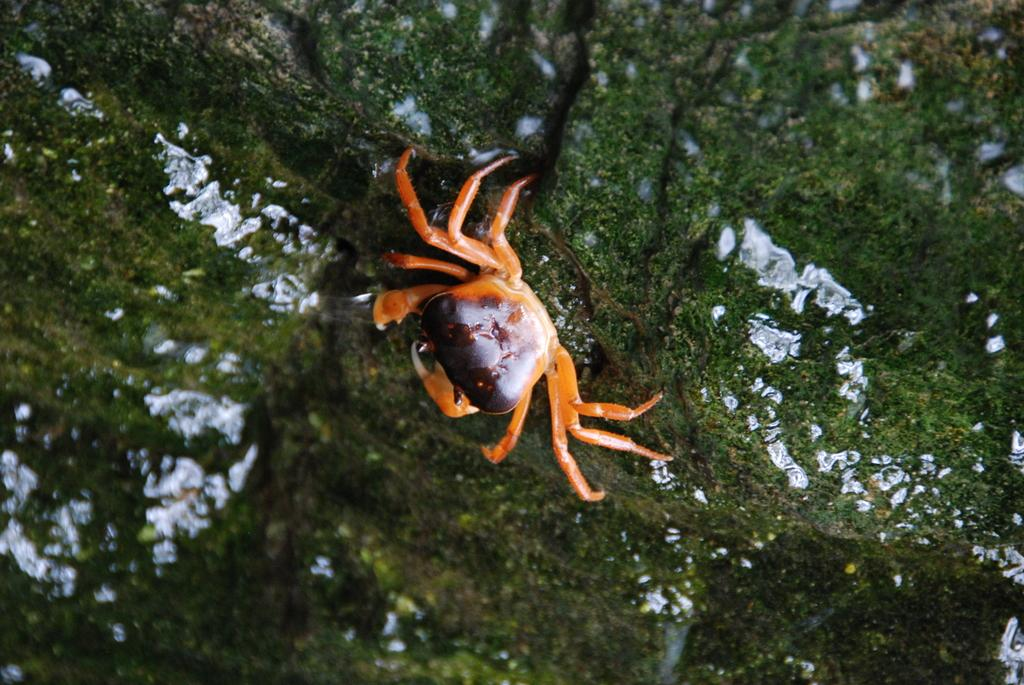What is the main subject in the center of the image? There is a crab in the center of the image. Can you describe the appearance of the crab? The crab is orange and brown in color. What can be seen in the background of the image? There are trees and a few other objects in the background of the image. What is the crab thinking about in the image? Crabs do not have the ability to think or have a mind, so it is not possible to determine what the crab might be thinking about in the image. 